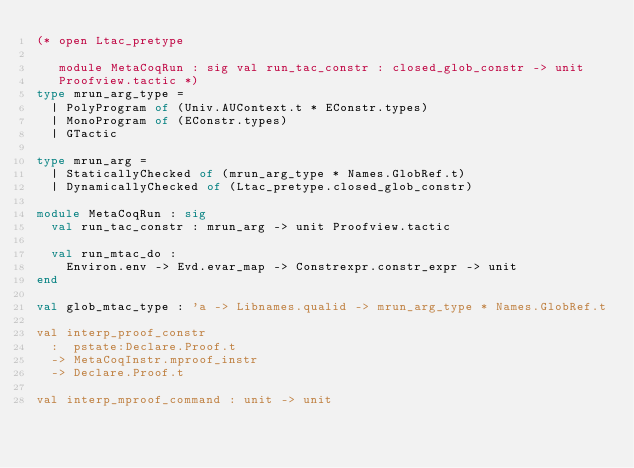<code> <loc_0><loc_0><loc_500><loc_500><_OCaml_>(* open Ltac_pretype

   module MetaCoqRun : sig val run_tac_constr : closed_glob_constr -> unit
   Proofview.tactic *)
type mrun_arg_type =
  | PolyProgram of (Univ.AUContext.t * EConstr.types)
  | MonoProgram of (EConstr.types)
  | GTactic

type mrun_arg =
  | StaticallyChecked of (mrun_arg_type * Names.GlobRef.t)
  | DynamicallyChecked of (Ltac_pretype.closed_glob_constr)

module MetaCoqRun : sig
  val run_tac_constr : mrun_arg -> unit Proofview.tactic

  val run_mtac_do :
    Environ.env -> Evd.evar_map -> Constrexpr.constr_expr -> unit
end

val glob_mtac_type : 'a -> Libnames.qualid -> mrun_arg_type * Names.GlobRef.t

val interp_proof_constr
  :  pstate:Declare.Proof.t
  -> MetaCoqInstr.mproof_instr
  -> Declare.Proof.t

val interp_mproof_command : unit -> unit
</code> 